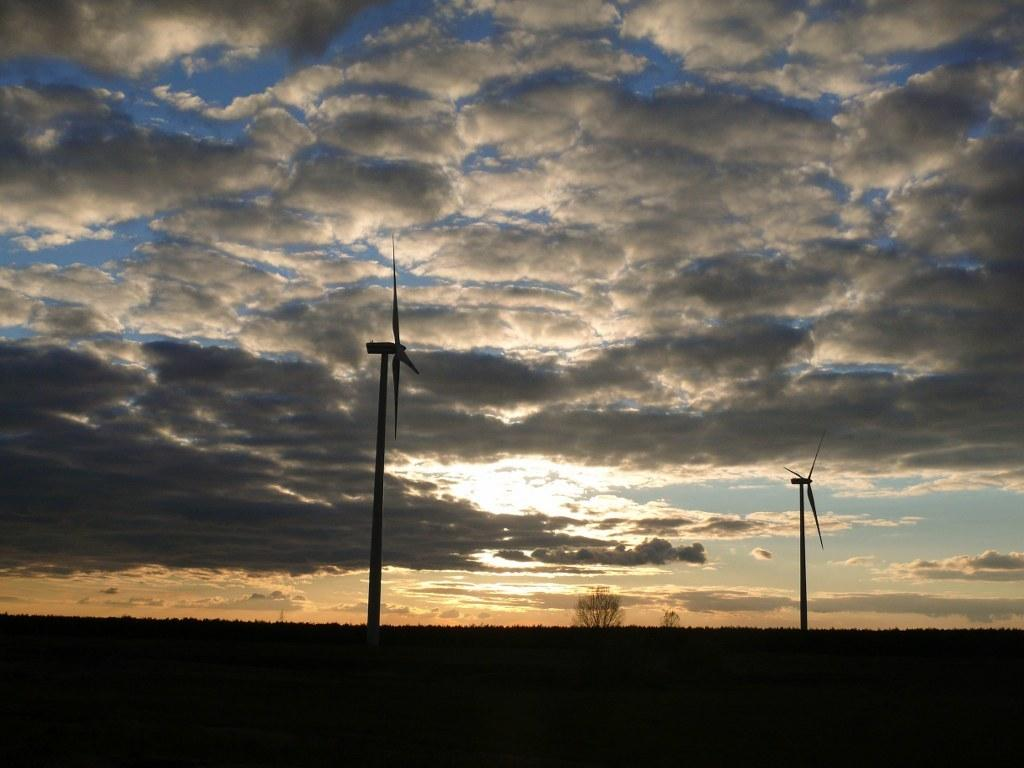What structures can be seen in the image? There are windmills in the image. What type of vegetation is present in the image? There are trees in the image. What is visible at the top of the image? The sky is visible at the top of the image. What color is the surface at the bottom of the image? The surface at the bottom of the image is black. Where is the stamp located in the image? There is no stamp present in the image. What type of family can be seen in the image? There is no family present in the image; it features windmills, trees, and a black surface. 